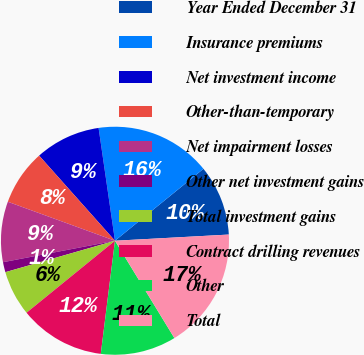Convert chart. <chart><loc_0><loc_0><loc_500><loc_500><pie_chart><fcel>Year Ended December 31<fcel>Insurance premiums<fcel>Net investment income<fcel>Other-than-temporary<fcel>Net impairment losses<fcel>Other net investment gains<fcel>Total investment gains<fcel>Contract drilling revenues<fcel>Other<fcel>Total<nl><fcel>10.0%<fcel>16.43%<fcel>9.29%<fcel>7.86%<fcel>8.57%<fcel>1.43%<fcel>6.43%<fcel>12.14%<fcel>10.71%<fcel>17.14%<nl></chart> 